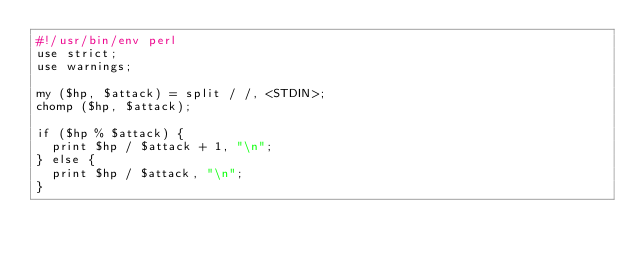Convert code to text. <code><loc_0><loc_0><loc_500><loc_500><_Perl_>#!/usr/bin/env perl
use strict;
use warnings;

my ($hp, $attack) = split / /, <STDIN>;
chomp ($hp, $attack);

if ($hp % $attack) {
  print $hp / $attack + 1, "\n";
} else {
  print $hp / $attack, "\n";
}
</code> 